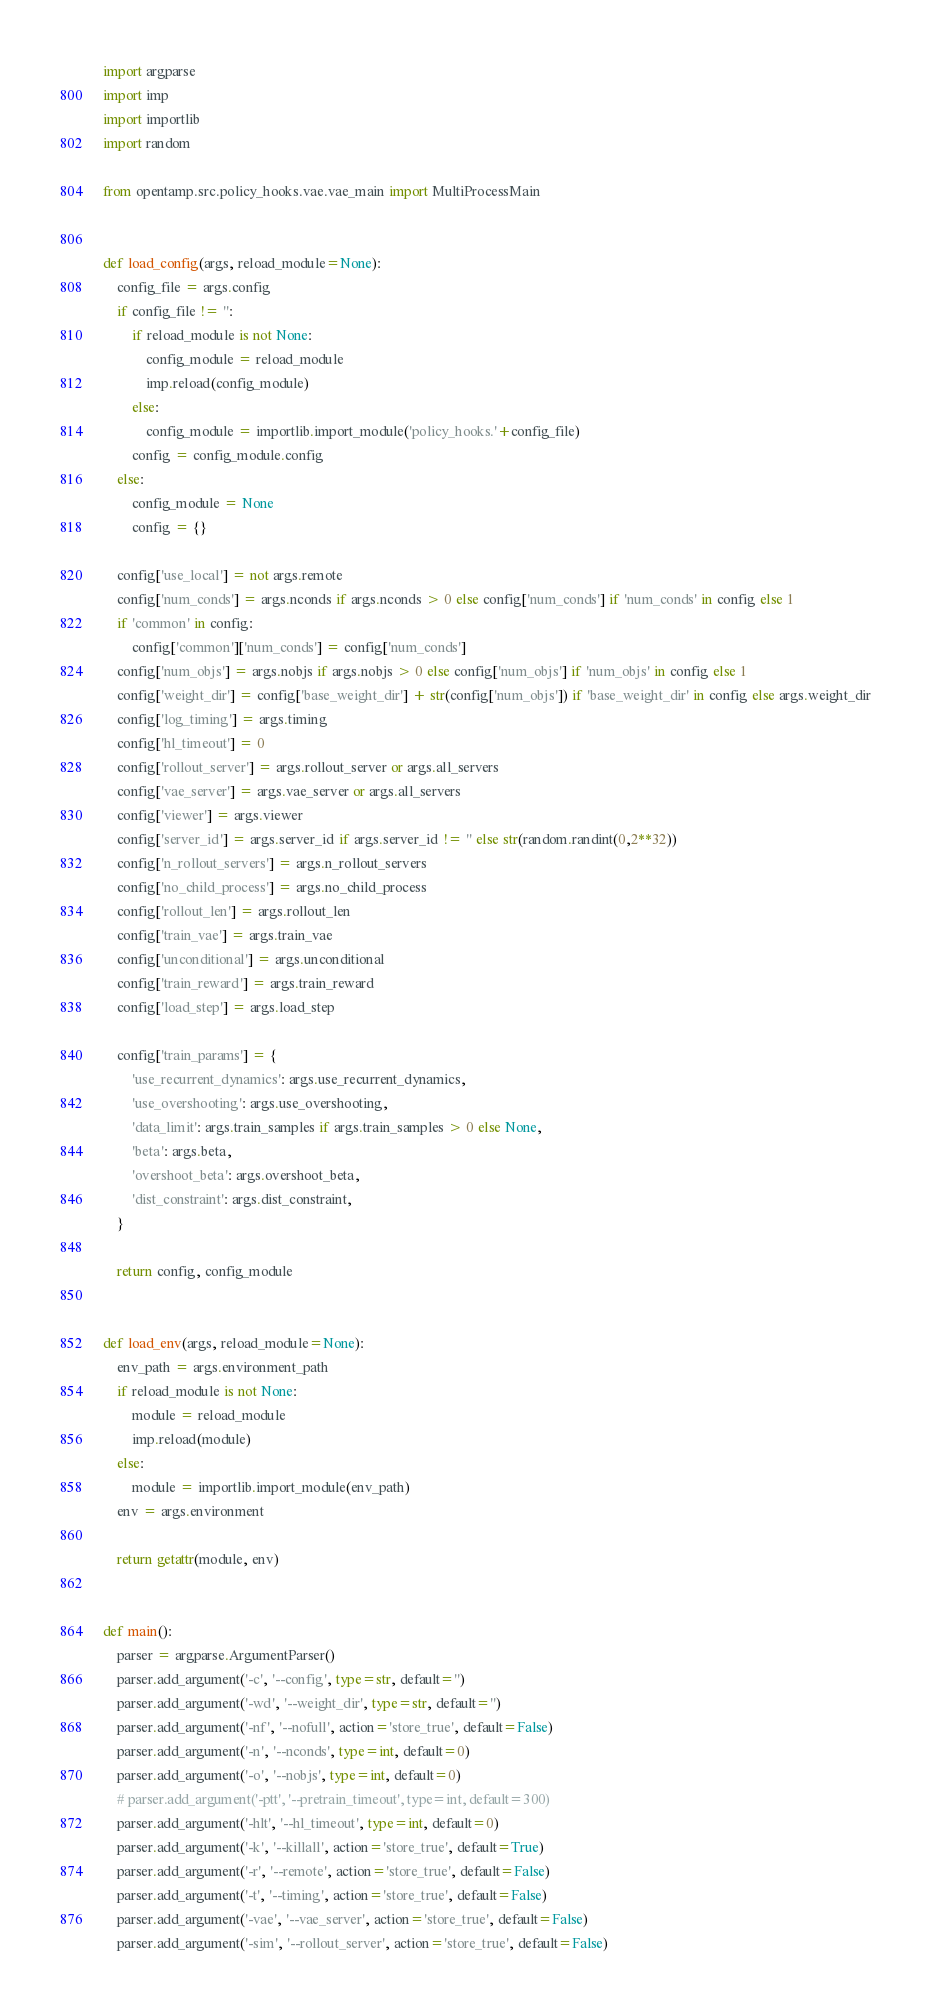Convert code to text. <code><loc_0><loc_0><loc_500><loc_500><_Python_>import argparse
import imp
import importlib
import random

from opentamp.src.policy_hooks.vae.vae_main import MultiProcessMain


def load_config(args, reload_module=None):
    config_file = args.config
    if config_file != '':
        if reload_module is not None:
            config_module = reload_module
            imp.reload(config_module)
        else:
            config_module = importlib.import_module('policy_hooks.'+config_file)
        config = config_module.config
    else:
        config_module = None
        config = {}

    config['use_local'] = not args.remote
    config['num_conds'] = args.nconds if args.nconds > 0 else config['num_conds'] if 'num_conds' in config else 1
    if 'common' in config:
        config['common']['num_conds'] = config['num_conds']
    config['num_objs'] = args.nobjs if args.nobjs > 0 else config['num_objs'] if 'num_objs' in config else 1
    config['weight_dir'] = config['base_weight_dir'] + str(config['num_objs']) if 'base_weight_dir' in config else args.weight_dir
    config['log_timing'] = args.timing
    config['hl_timeout'] = 0
    config['rollout_server'] = args.rollout_server or args.all_servers
    config['vae_server'] = args.vae_server or args.all_servers
    config['viewer'] = args.viewer
    config['server_id'] = args.server_id if args.server_id != '' else str(random.randint(0,2**32))
    config['n_rollout_servers'] = args.n_rollout_servers
    config['no_child_process'] = args.no_child_process
    config['rollout_len'] = args.rollout_len
    config['train_vae'] = args.train_vae
    config['unconditional'] = args.unconditional
    config['train_reward'] = args.train_reward
    config['load_step'] = args.load_step

    config['train_params'] = {
        'use_recurrent_dynamics': args.use_recurrent_dynamics,
        'use_overshooting': args.use_overshooting,
        'data_limit': args.train_samples if args.train_samples > 0 else None,
        'beta': args.beta,
        'overshoot_beta': args.overshoot_beta,
        'dist_constraint': args.dist_constraint,
    }

    return config, config_module


def load_env(args, reload_module=None):
    env_path = args.environment_path
    if reload_module is not None:
        module = reload_module
        imp.reload(module)
    else:
        module = importlib.import_module(env_path)
    env = args.environment

    return getattr(module, env)


def main():
    parser = argparse.ArgumentParser()
    parser.add_argument('-c', '--config', type=str, default='')
    parser.add_argument('-wd', '--weight_dir', type=str, default='')
    parser.add_argument('-nf', '--nofull', action='store_true', default=False)
    parser.add_argument('-n', '--nconds', type=int, default=0)
    parser.add_argument('-o', '--nobjs', type=int, default=0)
    # parser.add_argument('-ptt', '--pretrain_timeout', type=int, default=300)
    parser.add_argument('-hlt', '--hl_timeout', type=int, default=0)
    parser.add_argument('-k', '--killall', action='store_true', default=True)
    parser.add_argument('-r', '--remote', action='store_true', default=False)
    parser.add_argument('-t', '--timing', action='store_true', default=False)
    parser.add_argument('-vae', '--vae_server', action='store_true', default=False)
    parser.add_argument('-sim', '--rollout_server', action='store_true', default=False)</code> 